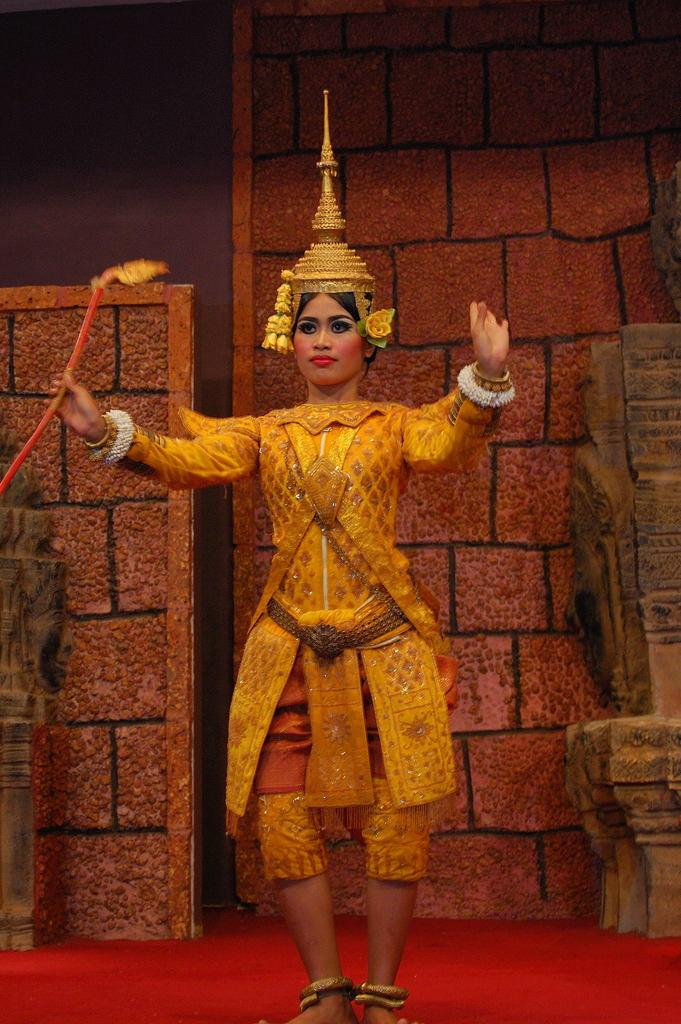Who is the main subject in the image? There is a woman in the image. What is the woman wearing? The woman is wearing traditional costume. What accessory is the woman wearing on her head? The woman has a crown on her head. What is the woman doing in the image? The woman is dancing. What color is the floor in the image? The floor is red. What is behind the woman in the image? There is a wall behind the woman. What type of soap is the woman using to clean her leg in the image? There is no soap or leg cleaning activity present in the image. 